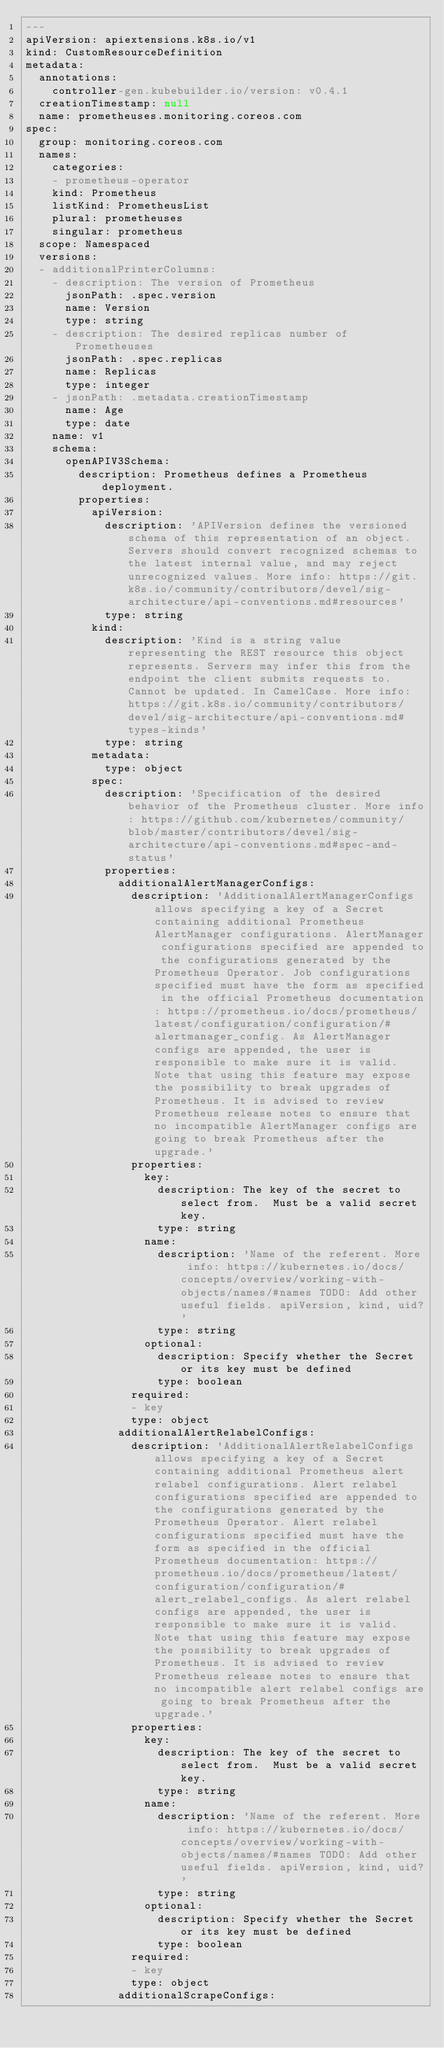<code> <loc_0><loc_0><loc_500><loc_500><_YAML_>---
apiVersion: apiextensions.k8s.io/v1
kind: CustomResourceDefinition
metadata:
  annotations:
    controller-gen.kubebuilder.io/version: v0.4.1
  creationTimestamp: null
  name: prometheuses.monitoring.coreos.com
spec:
  group: monitoring.coreos.com
  names:
    categories:
    - prometheus-operator
    kind: Prometheus
    listKind: PrometheusList
    plural: prometheuses
    singular: prometheus
  scope: Namespaced
  versions:
  - additionalPrinterColumns:
    - description: The version of Prometheus
      jsonPath: .spec.version
      name: Version
      type: string
    - description: The desired replicas number of Prometheuses
      jsonPath: .spec.replicas
      name: Replicas
      type: integer
    - jsonPath: .metadata.creationTimestamp
      name: Age
      type: date
    name: v1
    schema:
      openAPIV3Schema:
        description: Prometheus defines a Prometheus deployment.
        properties:
          apiVersion:
            description: 'APIVersion defines the versioned schema of this representation of an object. Servers should convert recognized schemas to the latest internal value, and may reject unrecognized values. More info: https://git.k8s.io/community/contributors/devel/sig-architecture/api-conventions.md#resources'
            type: string
          kind:
            description: 'Kind is a string value representing the REST resource this object represents. Servers may infer this from the endpoint the client submits requests to. Cannot be updated. In CamelCase. More info: https://git.k8s.io/community/contributors/devel/sig-architecture/api-conventions.md#types-kinds'
            type: string
          metadata:
            type: object
          spec:
            description: 'Specification of the desired behavior of the Prometheus cluster. More info: https://github.com/kubernetes/community/blob/master/contributors/devel/sig-architecture/api-conventions.md#spec-and-status'
            properties:
              additionalAlertManagerConfigs:
                description: 'AdditionalAlertManagerConfigs allows specifying a key of a Secret containing additional Prometheus AlertManager configurations. AlertManager configurations specified are appended to the configurations generated by the Prometheus Operator. Job configurations specified must have the form as specified in the official Prometheus documentation: https://prometheus.io/docs/prometheus/latest/configuration/configuration/#alertmanager_config. As AlertManager configs are appended, the user is responsible to make sure it is valid. Note that using this feature may expose the possibility to break upgrades of Prometheus. It is advised to review Prometheus release notes to ensure that no incompatible AlertManager configs are going to break Prometheus after the upgrade.'
                properties:
                  key:
                    description: The key of the secret to select from.  Must be a valid secret key.
                    type: string
                  name:
                    description: 'Name of the referent. More info: https://kubernetes.io/docs/concepts/overview/working-with-objects/names/#names TODO: Add other useful fields. apiVersion, kind, uid?'
                    type: string
                  optional:
                    description: Specify whether the Secret or its key must be defined
                    type: boolean
                required:
                - key
                type: object
              additionalAlertRelabelConfigs:
                description: 'AdditionalAlertRelabelConfigs allows specifying a key of a Secret containing additional Prometheus alert relabel configurations. Alert relabel configurations specified are appended to the configurations generated by the Prometheus Operator. Alert relabel configurations specified must have the form as specified in the official Prometheus documentation: https://prometheus.io/docs/prometheus/latest/configuration/configuration/#alert_relabel_configs. As alert relabel configs are appended, the user is responsible to make sure it is valid. Note that using this feature may expose the possibility to break upgrades of Prometheus. It is advised to review Prometheus release notes to ensure that no incompatible alert relabel configs are going to break Prometheus after the upgrade.'
                properties:
                  key:
                    description: The key of the secret to select from.  Must be a valid secret key.
                    type: string
                  name:
                    description: 'Name of the referent. More info: https://kubernetes.io/docs/concepts/overview/working-with-objects/names/#names TODO: Add other useful fields. apiVersion, kind, uid?'
                    type: string
                  optional:
                    description: Specify whether the Secret or its key must be defined
                    type: boolean
                required:
                - key
                type: object
              additionalScrapeConfigs:</code> 